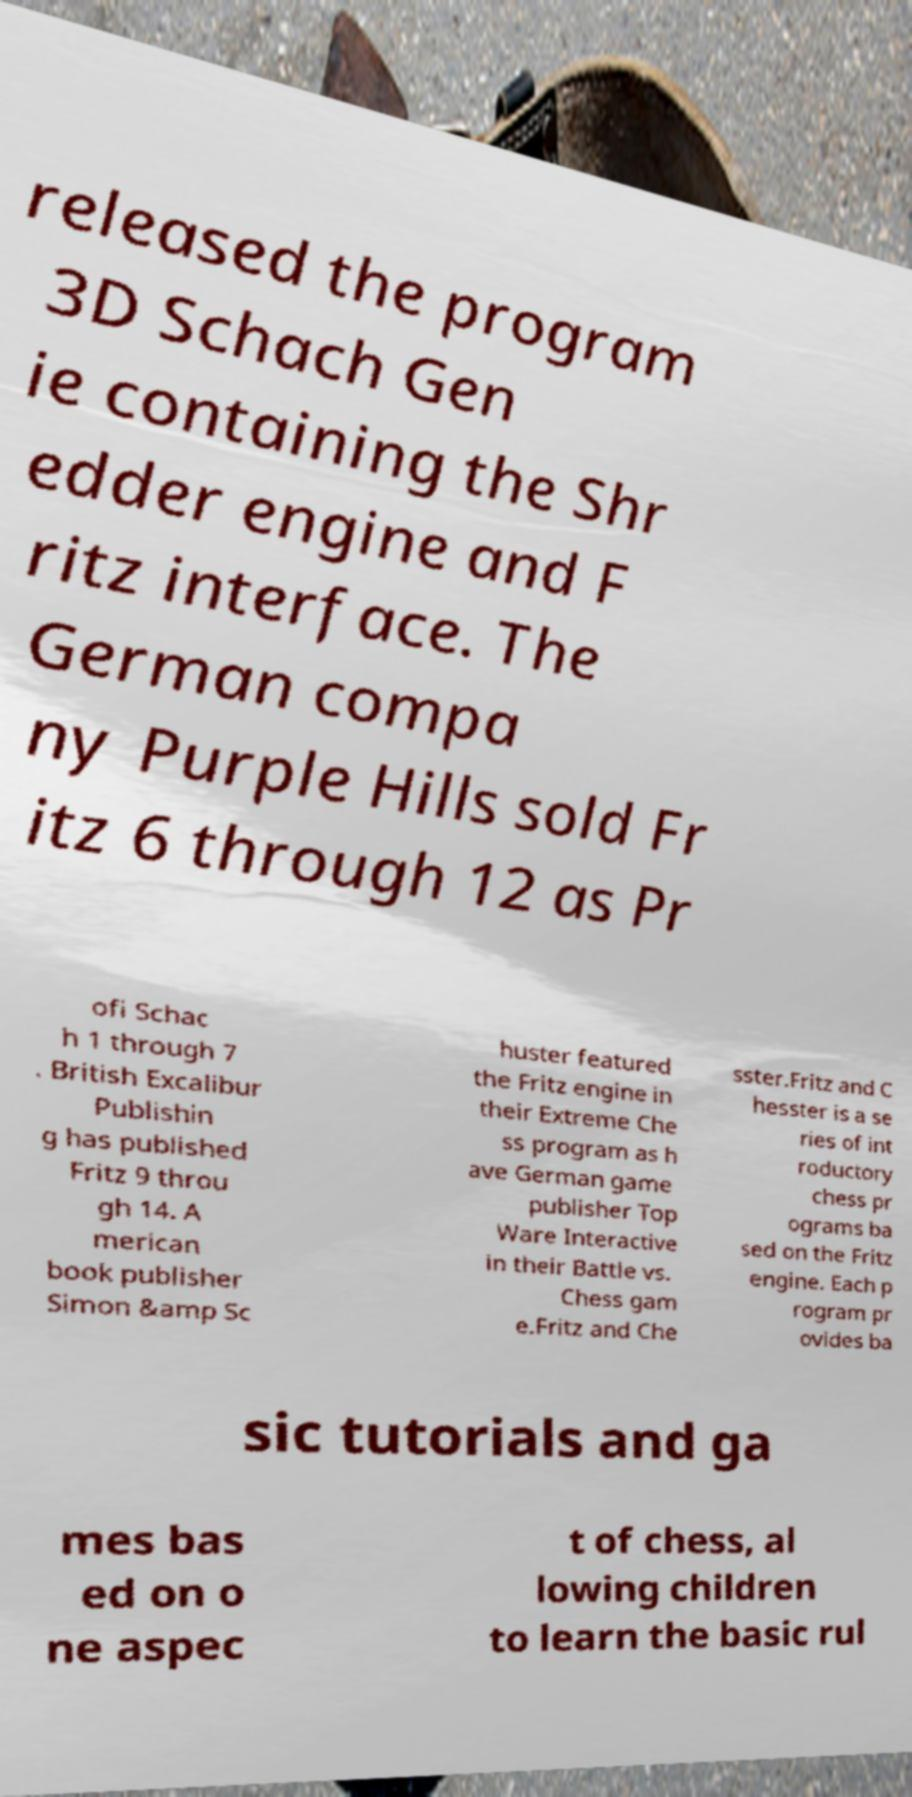Please identify and transcribe the text found in this image. released the program 3D Schach Gen ie containing the Shr edder engine and F ritz interface. The German compa ny Purple Hills sold Fr itz 6 through 12 as Pr ofi Schac h 1 through 7 . British Excalibur Publishin g has published Fritz 9 throu gh 14. A merican book publisher Simon &amp Sc huster featured the Fritz engine in their Extreme Che ss program as h ave German game publisher Top Ware Interactive in their Battle vs. Chess gam e.Fritz and Che sster.Fritz and C hesster is a se ries of int roductory chess pr ograms ba sed on the Fritz engine. Each p rogram pr ovides ba sic tutorials and ga mes bas ed on o ne aspec t of chess, al lowing children to learn the basic rul 